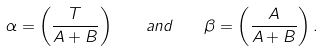<formula> <loc_0><loc_0><loc_500><loc_500>\alpha = \left ( \frac { T } { A + B } \right ) \quad a n d \quad \beta = \left ( \frac { A } { A + B } \right ) .</formula> 